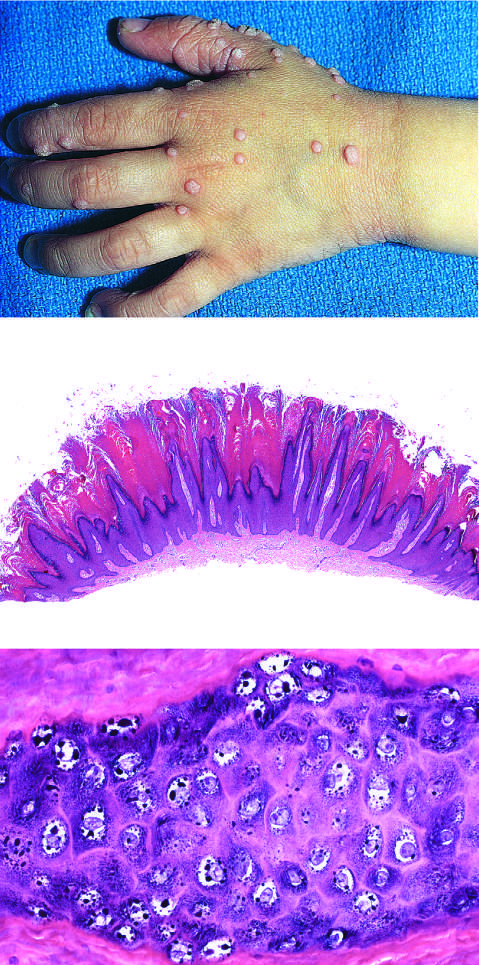re pallor or halos around nuclei, prominent keratohyalin granules, and related cytopathic changes seen at higher magnification?
Answer the question using a single word or phrase. Yes 